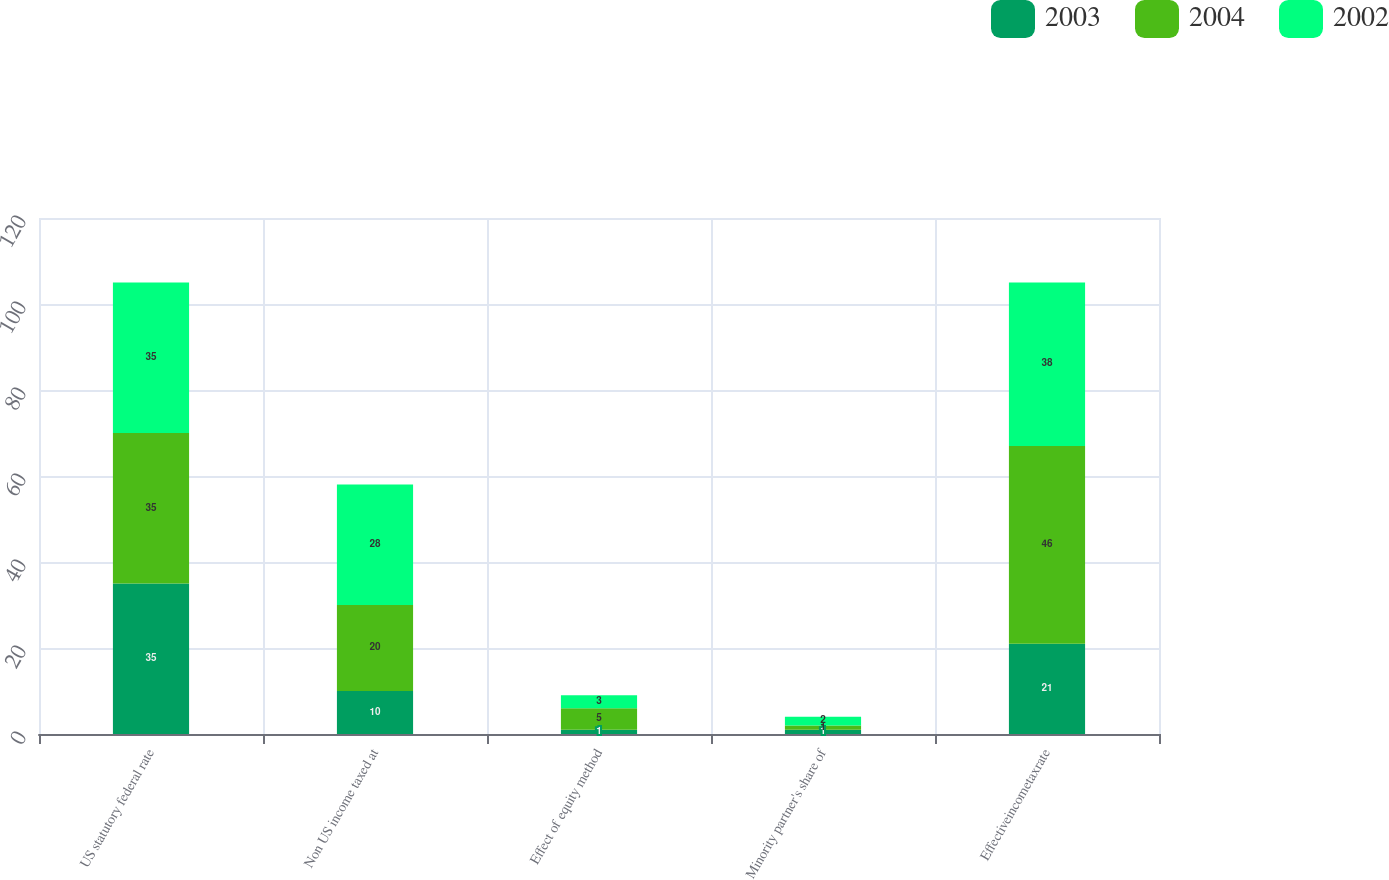Convert chart. <chart><loc_0><loc_0><loc_500><loc_500><stacked_bar_chart><ecel><fcel>US statutory federal rate<fcel>Non US income taxed at<fcel>Effect of equity method<fcel>Minority partner's share of<fcel>Effectiveincometaxrate<nl><fcel>2003<fcel>35<fcel>10<fcel>1<fcel>1<fcel>21<nl><fcel>2004<fcel>35<fcel>20<fcel>5<fcel>1<fcel>46<nl><fcel>2002<fcel>35<fcel>28<fcel>3<fcel>2<fcel>38<nl></chart> 